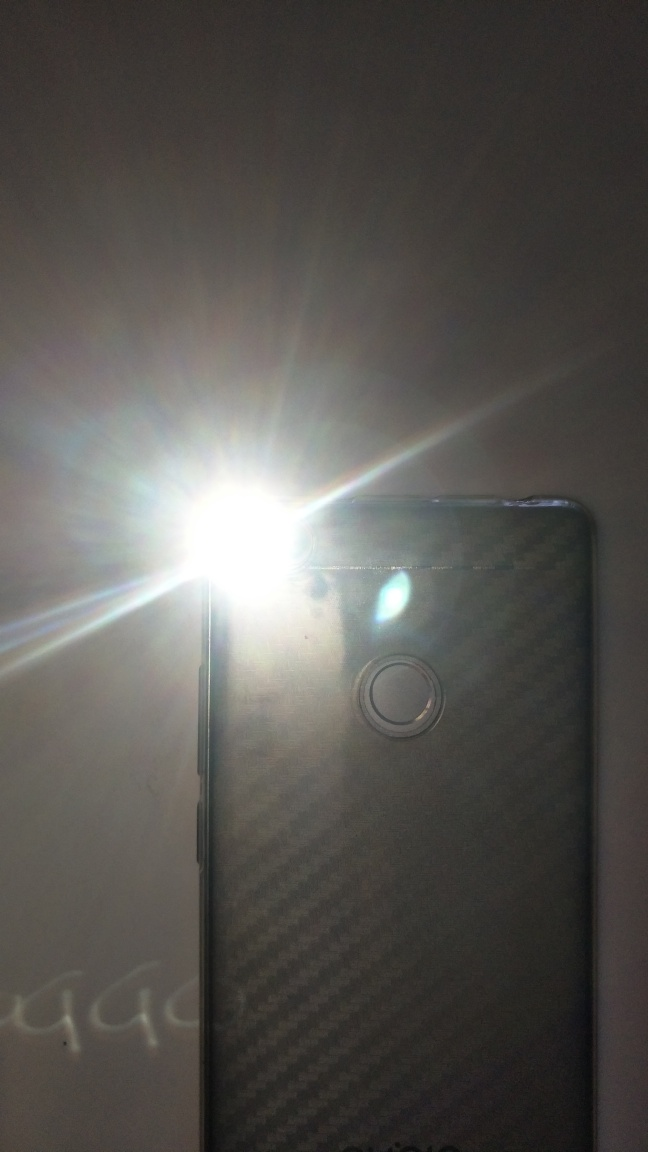How does the light from the flash affect the photo? The intense light from the flash can cause a number of effects in a photo. It can illuminate the scene, reduce shadows, sometimes cause red-eye, or in this case, create a flare in the image which might be used for artistic effect or considered an unintended glare. 